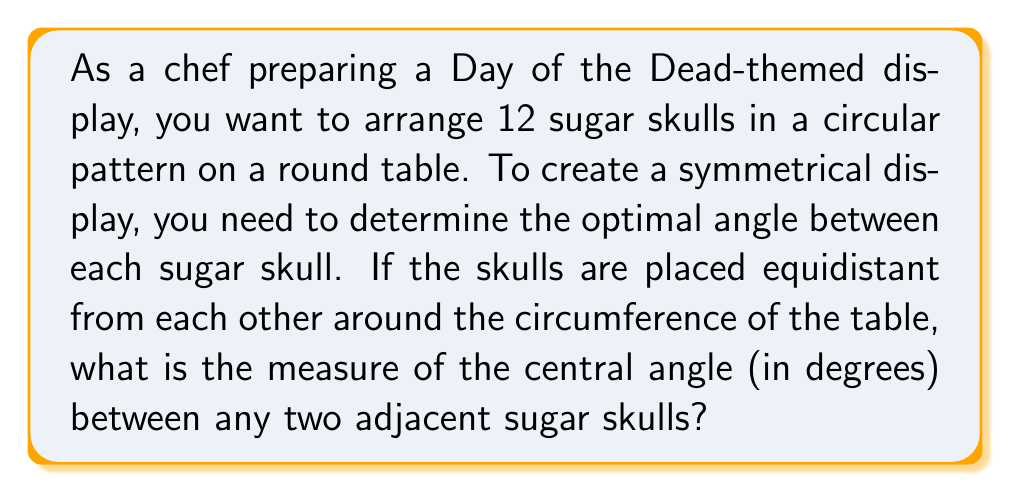Can you answer this question? To solve this problem, we need to consider the following steps:

1. Recall that a full circle contains 360°.

2. We need to divide the full circle equally among the 12 sugar skulls.

3. The formula to calculate the central angle between adjacent objects in a circular arrangement is:

   $$\text{Central Angle} = \frac{360°}{\text{Number of Objects}}$$

4. In this case, we have 12 sugar skulls, so we can substitute this into our formula:

   $$\text{Central Angle} = \frac{360°}{12}$$

5. Simplify the fraction:

   $$\text{Central Angle} = 30°$$

To visualize this arrangement, we can use the following diagram:

[asy]
import geometry;

size(200);
draw(circle((0,0),1));
for(int i=0; i<12; ++i) {
  dot(dir(i*30), red);
}
draw(arc((0,0),1,0,30), blue);
label("30°", (0.7,0.2), blue);
[/asy]

In this diagram, the red dots represent the sugar skulls, and the blue arc shows the 30° angle between adjacent skulls.
Answer: The optimal central angle between adjacent sugar skulls in the symmetrical circular display is $30°$. 